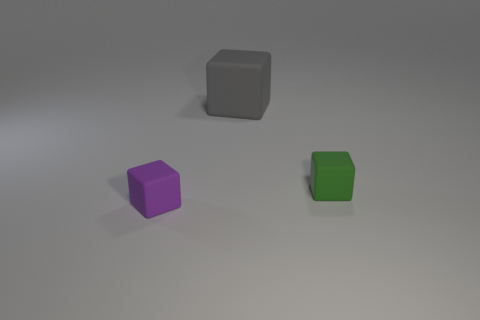What might these blocks represent in a symbolic way? Symbolically, these blocks might represent various concepts, such as the basic building elements in a system, the simplicity of form and design, or the idea of individual components that, when combined, could create a more complex structure. Could they represent any specific concepts in mathematics or art? In mathematics, these blocks could be used to demonstrate geometric principles, such as volume and spatial relationships. In art, they might symbolize minimalism or serve as a reference to the Bauhaus movement's emphasis on simplified forms and primary colors. 